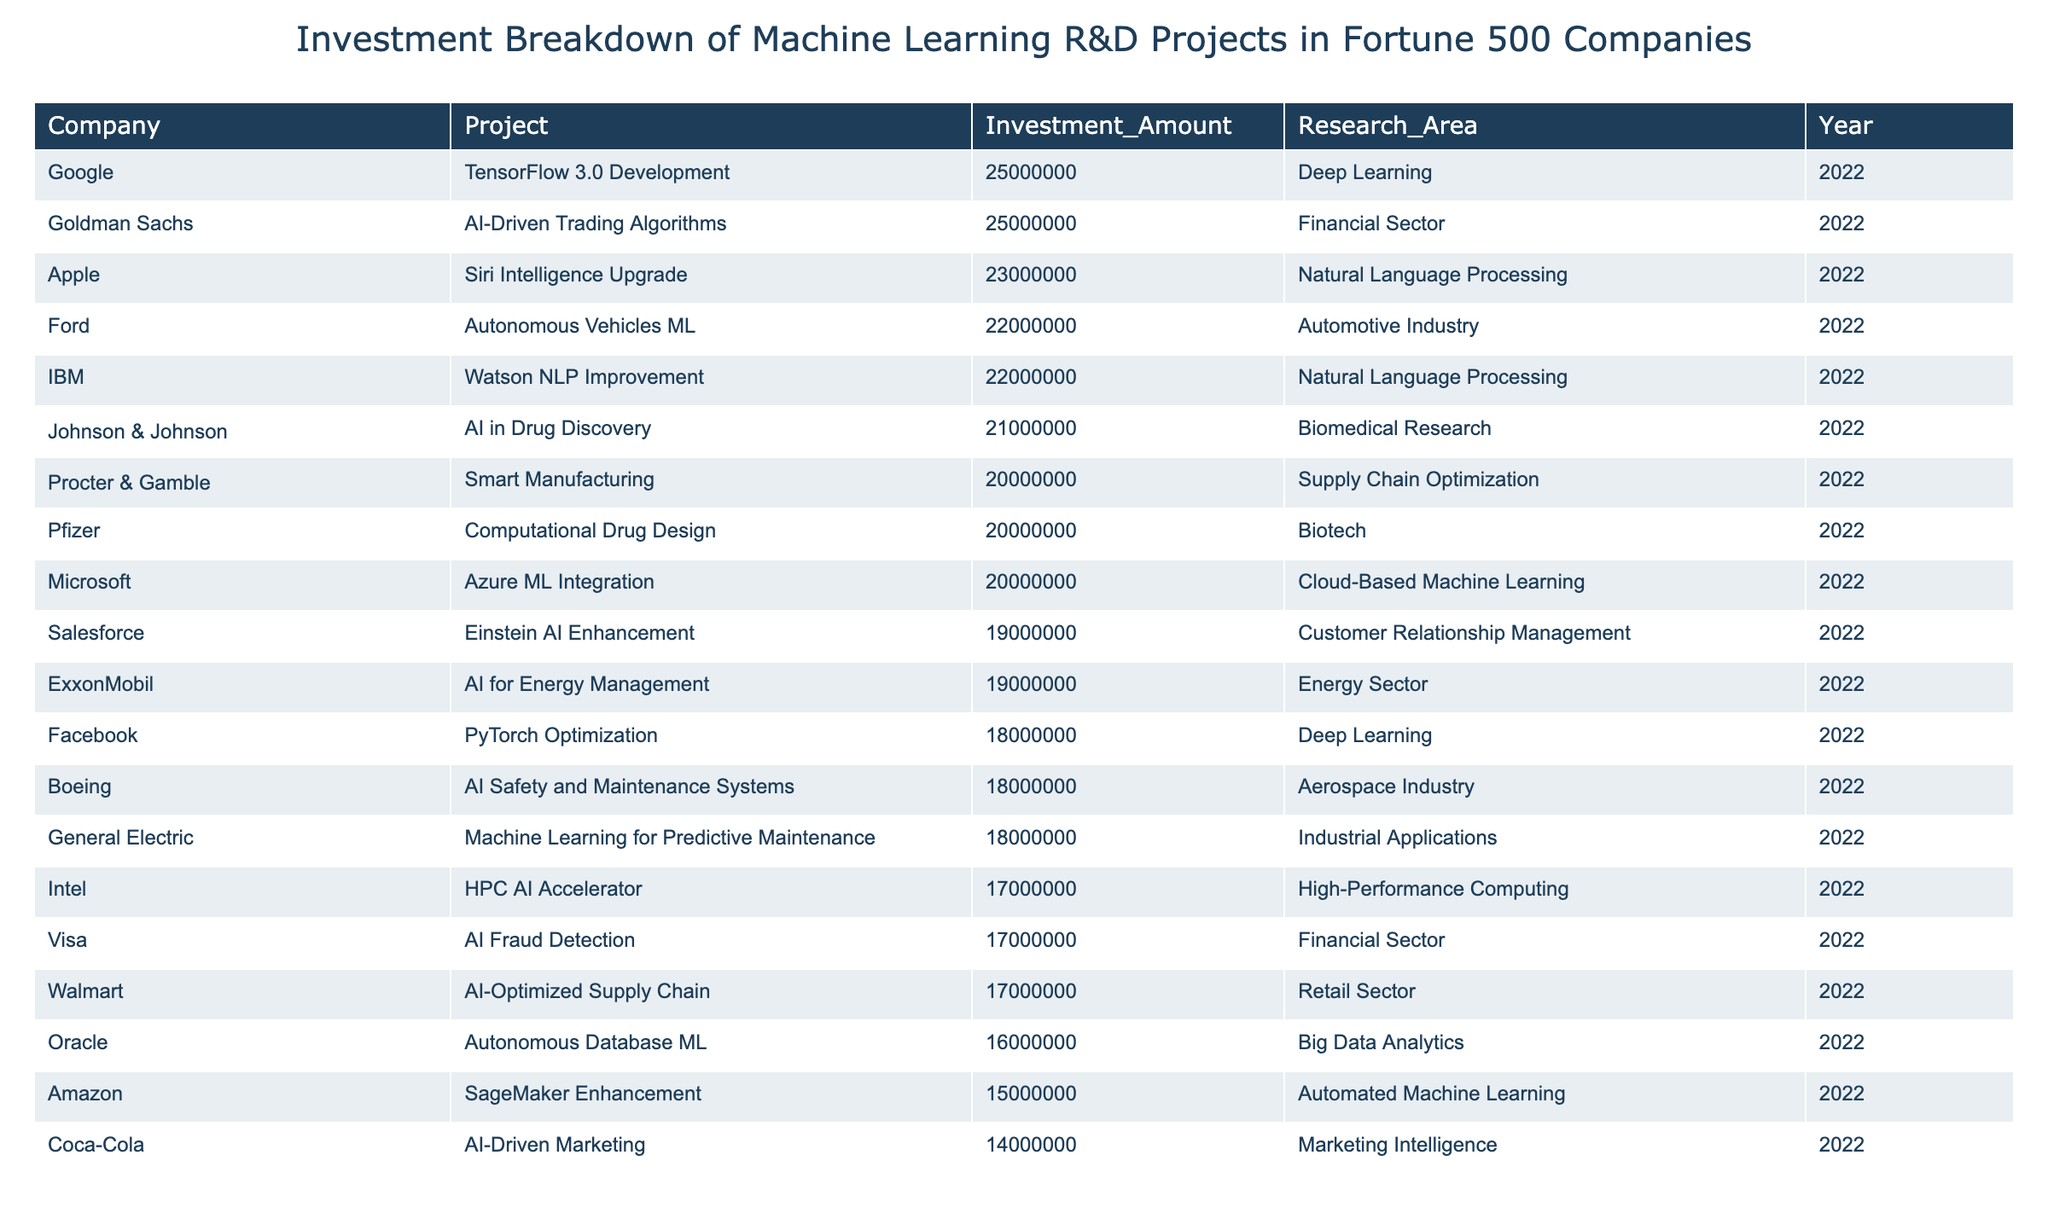What is the highest investment amount listed in the table? By reviewing the "Investment_Amount" column, the highest value is the largest numerical entry. Scanning through the amounts, the highest investment is 25,000,000 from both Google and Goldman Sachs for their respective projects.
Answer: 25,000,000 Which company invested in Natural Language Processing projects? By looking at the "Research_Area" column, we find companies with "Natural Language Processing". The entries for IBM and Apple indicate they both focused their investments on this research area.
Answer: IBM and Apple What is the total investment amount from companies involved in the Financial Sector? The companies in the "Financial Sector" are Visa and Goldman Sachs with investment amounts of 17,000,000 and 25,000,000 respectively. Summing these amounts gives 17,000,000 + 25,000,000 = 42,000,000.
Answer: 42,000,000 Is there a project in the Aerospace Industry listed in the table? By checking the "Research_Area" column, we see that Boeing's project is categorized under "Aerospace Industry", confirming that a project in this area is indeed listed.
Answer: Yes What is the average investment amount for projects related to Deep Learning? The investments for Deep Learning projects are from Google (25,000,000) and Facebook (18,000,000). Adding these amounts gives 25,000,000 + 18,000,000 = 43,000,000, and dividing by 2 (the number of projects) results in an average of 21,500,000.
Answer: 21,500,000 Which company has the lowest investment amount and what is it? By scanning the "Investment_Amount" column for the smallest value, we find Coca-Cola, which has invested 14,000,000 in AI-Driven Marketing.
Answer: Coca-Cola, 14,000,000 List all research areas where investments were made totaling more than 20 million. Assessing the table, we find the projects with investments of more than 20 million in the following areas: Deep Learning, Natural Language Processing, Cloud-Based Machine Learning, and Automotive Industry.
Answer: Deep Learning, NLP, Cloud-Based Machine Learning, Automotive Industry What is the sum of investments in the Marketing Intelligence and Customer Relationship Management research areas? The "Investment_Amount" for Marketing Intelligence (Coca-Cola) is 14,000,000, and for Customer Relationship Management (Salesforce) it’s 19,000,000. Adding these together gives 14,000,000 + 19,000,000 = 33,000,000.
Answer: 33,000,000 